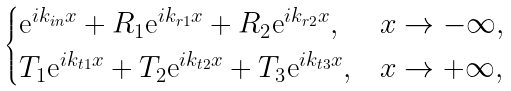Convert formula to latex. <formula><loc_0><loc_0><loc_500><loc_500>\begin{cases} \text {e} ^ { i k _ { i n } x } + R _ { 1 } \text {e} ^ { i k _ { r 1 } x } + R _ { 2 } \text {e} ^ { i k _ { r 2 } x } , & x \rightarrow - \infty , \\ T _ { 1 } \text {e} ^ { i k _ { t 1 } x } + T _ { 2 } \text {e} ^ { i k _ { t 2 } x } + T _ { 3 } \text {e} ^ { i k _ { t 3 } x } , & x \rightarrow + \infty , \end{cases}</formula> 